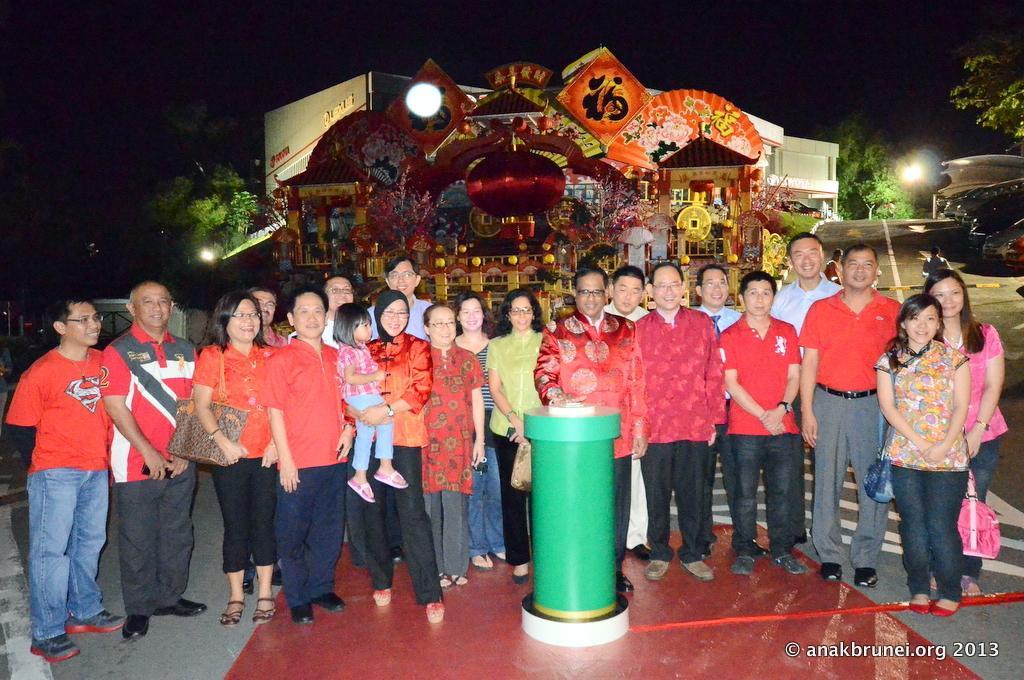Please provide a concise description of this image. In this image, we can see some people standing and in the background we can see some trees and there is a building. 